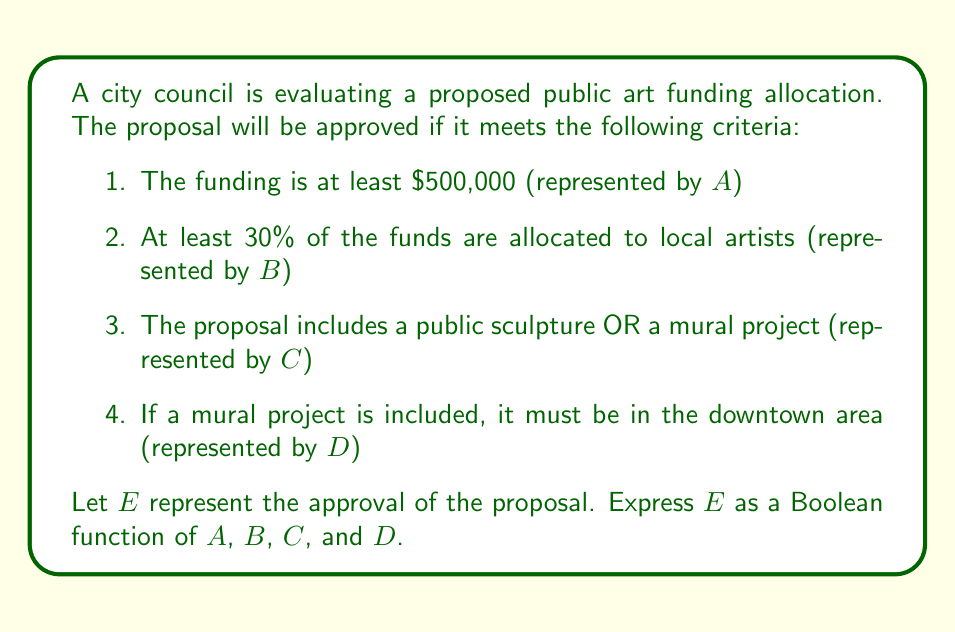Show me your answer to this math problem. To express E as a Boolean function of A, B, C, and D, we need to translate the given criteria into Boolean logic:

1. The funding must be at least $500,000: This is simply represented by A.

2. At least 30% of the funds are allocated to local artists: This is represented by B.

3. The proposal includes a public sculpture OR a mural project: This is represented by C.

4. If a mural project is included, it must be in the downtown area: This can be represented as an implication. In Boolean logic, an implication P → Q is equivalent to ¬P ∨ Q. In this case, "mural project" implies "downtown area", which can be written as ¬(mural project) ∨ (downtown area).

However, we don't have separate variables for "mural project" and "public sculpture". We only have C, which represents "public sculpture OR mural project". Let's assume that if C is true and D is false, it means there's a public sculpture but no mural project.

Therefore, the fourth condition can be represented as: ¬C ∨ D

Now, we can combine these conditions using AND operations:

$$ E = A \land B \land C \land (\neg C \lor D) $$

This Boolean expression represents that the proposal is approved (E is true) if and only if all the conditions are met.
Answer: $$ E = A \land B \land C \land (\neg C \lor D) $$ 